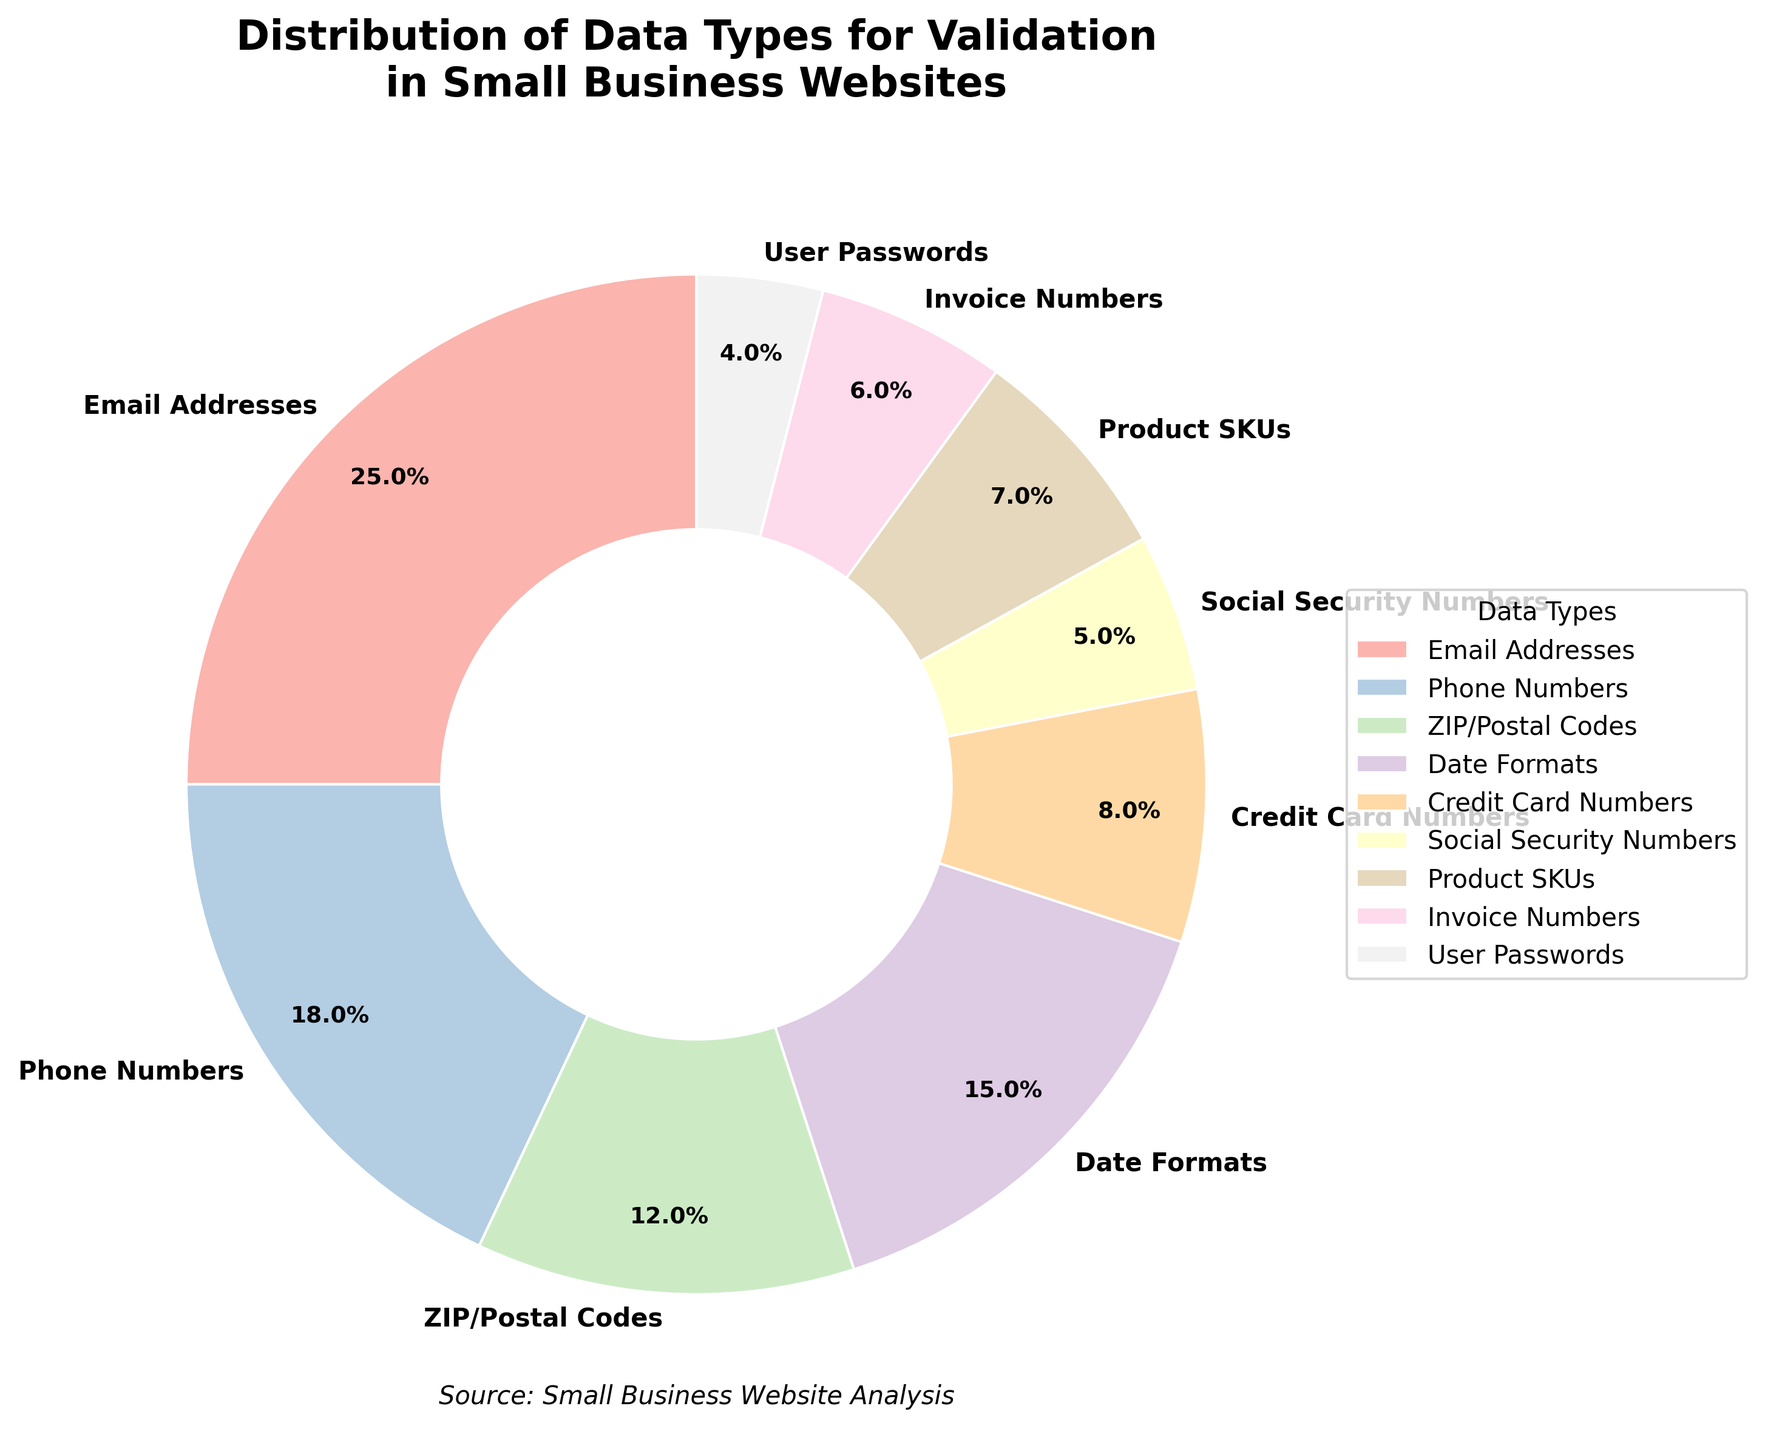Which data type has the largest percentage in the pie chart? By visually inspecting the pie chart, the segment with the label "Email Addresses" is the largest. It occupies 25% of the chart, which is higher than any other data type.
Answer: Email Addresses What is the combined percentage of ZIP/Postal Codes and Product SKUs? Locate the segments for ZIP/Postal Codes and Product SKUs. ZIP/Postal Codes have 12% and Product SKUs have 7%. Adding these together gives 12% + 7% = 19%.
Answer: 19% Are there more Email Addresses or Phone Numbers? The segment for Email Addresses is 25%, and the segment for Phone Numbers is 18%. Since 25% is greater than 18%, there are more Email Addresses.
Answer: Email Addresses Which data type has the smallest percentage, and what is it? By observing the pie chart, the smallest segment belongs to User Passwords, which has a percentage of 4%.
Answer: User Passwords How much larger is the percentage of Credit Card Numbers compared to User Passwords? Locate the segments for Credit Card Numbers and User Passwords. Credit Card Numbers have 8% and User Passwords have 4%. The difference is 8% - 4% = 4%.
Answer: 4% What is the average percentage of Social Security Numbers, Product SKUs, and Invoice Numbers? The percentages for Social Security Numbers, Product SKUs, and Invoice Numbers are 5%, 7%, and 6% respectively. The average is calculated as (5 + 7 + 6) / 3 = 18 / 3 = 6%.
Answer: 6% Which data type has a higher percentage: Date Formats or ZIP/Postal Codes? Date Formats have a percentage of 15%, while ZIP/Postal Codes have a percentage of 12%. Therefore, Date Formats have a higher percentage.
Answer: Date Formats How does the percentage of Phone Numbers compare to the combined percentage of Credit Card Numbers and User Passwords? Phone Numbers have a percentage of 18%. The combined percentage of Credit Card Numbers (8%) and User Passwords (4%) is 8% + 4% = 12%. Since 18% is greater than 12%, Phone Numbers have a higher percentage.
Answer: Phone Numbers What is the difference between the percentage of Email Addresses and the combined percentage of Social Security Numbers and Invoice Numbers? The percentage of Email Addresses is 25%. Combined percentage of Social Security Numbers (5%) and Invoice Numbers (6%) is 5% + 6% = 11%. The difference is 25% - 11% = 14%.
Answer: 14% Which three data types together account for approximately half of the pie chart? The data types and their respective percentages are: Email Addresses (25%), Phone Numbers (18%), and Date Formats (15%). Summing these gives 25% + 18% + 15% = 58%, which is close to half (50%).
Answer: Email Addresses, Phone Numbers, Date Formats 